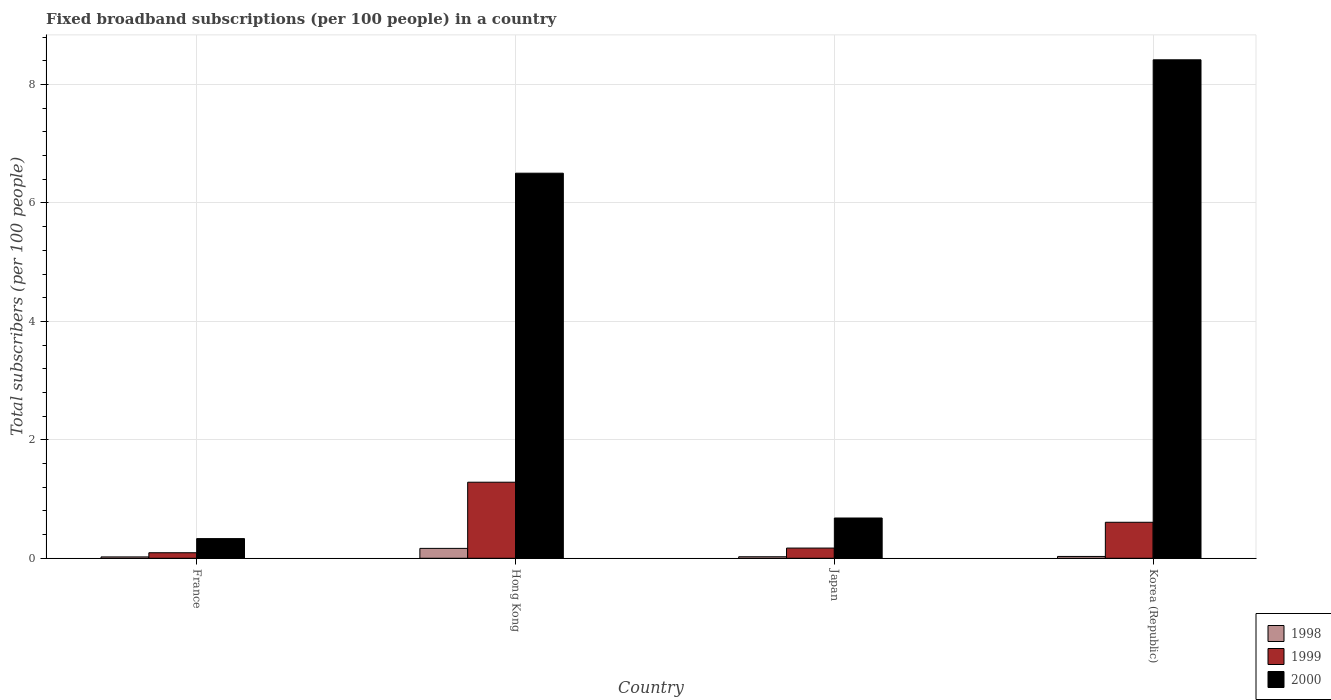How many different coloured bars are there?
Your answer should be very brief. 3. Are the number of bars per tick equal to the number of legend labels?
Give a very brief answer. Yes. How many bars are there on the 2nd tick from the left?
Your response must be concise. 3. What is the label of the 2nd group of bars from the left?
Your response must be concise. Hong Kong. In how many cases, is the number of bars for a given country not equal to the number of legend labels?
Your response must be concise. 0. What is the number of broadband subscriptions in 2000 in France?
Your answer should be compact. 0.33. Across all countries, what is the maximum number of broadband subscriptions in 2000?
Make the answer very short. 8.42. Across all countries, what is the minimum number of broadband subscriptions in 1999?
Keep it short and to the point. 0.09. In which country was the number of broadband subscriptions in 1999 maximum?
Your answer should be compact. Hong Kong. What is the total number of broadband subscriptions in 2000 in the graph?
Offer a very short reply. 15.93. What is the difference between the number of broadband subscriptions in 1998 in France and that in Japan?
Provide a short and direct response. -0. What is the difference between the number of broadband subscriptions in 1998 in Japan and the number of broadband subscriptions in 2000 in Korea (Republic)?
Ensure brevity in your answer.  -8.39. What is the average number of broadband subscriptions in 2000 per country?
Your answer should be compact. 3.98. What is the difference between the number of broadband subscriptions of/in 1998 and number of broadband subscriptions of/in 1999 in Korea (Republic)?
Ensure brevity in your answer.  -0.58. What is the ratio of the number of broadband subscriptions in 1999 in Hong Kong to that in Japan?
Offer a very short reply. 7.46. Is the number of broadband subscriptions in 1999 in Hong Kong less than that in Japan?
Make the answer very short. No. What is the difference between the highest and the second highest number of broadband subscriptions in 2000?
Your answer should be compact. 7.74. What is the difference between the highest and the lowest number of broadband subscriptions in 1999?
Give a very brief answer. 1.19. In how many countries, is the number of broadband subscriptions in 1999 greater than the average number of broadband subscriptions in 1999 taken over all countries?
Offer a very short reply. 2. Is the sum of the number of broadband subscriptions in 1999 in Hong Kong and Korea (Republic) greater than the maximum number of broadband subscriptions in 2000 across all countries?
Keep it short and to the point. No. What does the 2nd bar from the left in France represents?
Offer a terse response. 1999. What does the 3rd bar from the right in Japan represents?
Offer a terse response. 1998. How many bars are there?
Provide a succinct answer. 12. How many countries are there in the graph?
Ensure brevity in your answer.  4. What is the difference between two consecutive major ticks on the Y-axis?
Give a very brief answer. 2. How many legend labels are there?
Offer a terse response. 3. How are the legend labels stacked?
Ensure brevity in your answer.  Vertical. What is the title of the graph?
Offer a very short reply. Fixed broadband subscriptions (per 100 people) in a country. What is the label or title of the X-axis?
Your response must be concise. Country. What is the label or title of the Y-axis?
Keep it short and to the point. Total subscribers (per 100 people). What is the Total subscribers (per 100 people) of 1998 in France?
Give a very brief answer. 0.02. What is the Total subscribers (per 100 people) in 1999 in France?
Offer a terse response. 0.09. What is the Total subscribers (per 100 people) of 2000 in France?
Your answer should be very brief. 0.33. What is the Total subscribers (per 100 people) in 1998 in Hong Kong?
Provide a succinct answer. 0.17. What is the Total subscribers (per 100 people) in 1999 in Hong Kong?
Provide a succinct answer. 1.28. What is the Total subscribers (per 100 people) in 2000 in Hong Kong?
Offer a terse response. 6.5. What is the Total subscribers (per 100 people) in 1998 in Japan?
Provide a short and direct response. 0.03. What is the Total subscribers (per 100 people) in 1999 in Japan?
Your answer should be very brief. 0.17. What is the Total subscribers (per 100 people) in 2000 in Japan?
Offer a very short reply. 0.68. What is the Total subscribers (per 100 people) in 1998 in Korea (Republic)?
Offer a terse response. 0.03. What is the Total subscribers (per 100 people) of 1999 in Korea (Republic)?
Keep it short and to the point. 0.61. What is the Total subscribers (per 100 people) in 2000 in Korea (Republic)?
Your response must be concise. 8.42. Across all countries, what is the maximum Total subscribers (per 100 people) of 1998?
Keep it short and to the point. 0.17. Across all countries, what is the maximum Total subscribers (per 100 people) of 1999?
Make the answer very short. 1.28. Across all countries, what is the maximum Total subscribers (per 100 people) in 2000?
Keep it short and to the point. 8.42. Across all countries, what is the minimum Total subscribers (per 100 people) of 1998?
Provide a succinct answer. 0.02. Across all countries, what is the minimum Total subscribers (per 100 people) in 1999?
Your response must be concise. 0.09. Across all countries, what is the minimum Total subscribers (per 100 people) in 2000?
Your answer should be very brief. 0.33. What is the total Total subscribers (per 100 people) of 1998 in the graph?
Provide a succinct answer. 0.25. What is the total Total subscribers (per 100 people) of 1999 in the graph?
Your answer should be compact. 2.16. What is the total Total subscribers (per 100 people) in 2000 in the graph?
Keep it short and to the point. 15.93. What is the difference between the Total subscribers (per 100 people) of 1998 in France and that in Hong Kong?
Ensure brevity in your answer.  -0.14. What is the difference between the Total subscribers (per 100 people) of 1999 in France and that in Hong Kong?
Offer a very short reply. -1.19. What is the difference between the Total subscribers (per 100 people) of 2000 in France and that in Hong Kong?
Offer a terse response. -6.17. What is the difference between the Total subscribers (per 100 people) of 1998 in France and that in Japan?
Provide a short and direct response. -0. What is the difference between the Total subscribers (per 100 people) in 1999 in France and that in Japan?
Offer a terse response. -0.08. What is the difference between the Total subscribers (per 100 people) of 2000 in France and that in Japan?
Your answer should be very brief. -0.35. What is the difference between the Total subscribers (per 100 people) of 1998 in France and that in Korea (Republic)?
Your answer should be very brief. -0.01. What is the difference between the Total subscribers (per 100 people) in 1999 in France and that in Korea (Republic)?
Give a very brief answer. -0.51. What is the difference between the Total subscribers (per 100 people) in 2000 in France and that in Korea (Republic)?
Make the answer very short. -8.09. What is the difference between the Total subscribers (per 100 people) of 1998 in Hong Kong and that in Japan?
Ensure brevity in your answer.  0.14. What is the difference between the Total subscribers (per 100 people) of 1999 in Hong Kong and that in Japan?
Provide a succinct answer. 1.11. What is the difference between the Total subscribers (per 100 people) in 2000 in Hong Kong and that in Japan?
Offer a terse response. 5.82. What is the difference between the Total subscribers (per 100 people) of 1998 in Hong Kong and that in Korea (Republic)?
Provide a short and direct response. 0.14. What is the difference between the Total subscribers (per 100 people) in 1999 in Hong Kong and that in Korea (Republic)?
Make the answer very short. 0.68. What is the difference between the Total subscribers (per 100 people) of 2000 in Hong Kong and that in Korea (Republic)?
Your response must be concise. -1.91. What is the difference between the Total subscribers (per 100 people) in 1998 in Japan and that in Korea (Republic)?
Keep it short and to the point. -0.01. What is the difference between the Total subscribers (per 100 people) in 1999 in Japan and that in Korea (Republic)?
Give a very brief answer. -0.44. What is the difference between the Total subscribers (per 100 people) in 2000 in Japan and that in Korea (Republic)?
Provide a succinct answer. -7.74. What is the difference between the Total subscribers (per 100 people) of 1998 in France and the Total subscribers (per 100 people) of 1999 in Hong Kong?
Your answer should be compact. -1.26. What is the difference between the Total subscribers (per 100 people) in 1998 in France and the Total subscribers (per 100 people) in 2000 in Hong Kong?
Give a very brief answer. -6.48. What is the difference between the Total subscribers (per 100 people) in 1999 in France and the Total subscribers (per 100 people) in 2000 in Hong Kong?
Your answer should be compact. -6.41. What is the difference between the Total subscribers (per 100 people) in 1998 in France and the Total subscribers (per 100 people) in 1999 in Japan?
Make the answer very short. -0.15. What is the difference between the Total subscribers (per 100 people) of 1998 in France and the Total subscribers (per 100 people) of 2000 in Japan?
Provide a succinct answer. -0.66. What is the difference between the Total subscribers (per 100 people) of 1999 in France and the Total subscribers (per 100 people) of 2000 in Japan?
Your response must be concise. -0.59. What is the difference between the Total subscribers (per 100 people) in 1998 in France and the Total subscribers (per 100 people) in 1999 in Korea (Republic)?
Give a very brief answer. -0.58. What is the difference between the Total subscribers (per 100 people) of 1998 in France and the Total subscribers (per 100 people) of 2000 in Korea (Republic)?
Your response must be concise. -8.39. What is the difference between the Total subscribers (per 100 people) of 1999 in France and the Total subscribers (per 100 people) of 2000 in Korea (Republic)?
Provide a succinct answer. -8.32. What is the difference between the Total subscribers (per 100 people) in 1998 in Hong Kong and the Total subscribers (per 100 people) in 1999 in Japan?
Give a very brief answer. -0.01. What is the difference between the Total subscribers (per 100 people) in 1998 in Hong Kong and the Total subscribers (per 100 people) in 2000 in Japan?
Your answer should be very brief. -0.51. What is the difference between the Total subscribers (per 100 people) in 1999 in Hong Kong and the Total subscribers (per 100 people) in 2000 in Japan?
Provide a short and direct response. 0.6. What is the difference between the Total subscribers (per 100 people) of 1998 in Hong Kong and the Total subscribers (per 100 people) of 1999 in Korea (Republic)?
Your response must be concise. -0.44. What is the difference between the Total subscribers (per 100 people) in 1998 in Hong Kong and the Total subscribers (per 100 people) in 2000 in Korea (Republic)?
Your response must be concise. -8.25. What is the difference between the Total subscribers (per 100 people) of 1999 in Hong Kong and the Total subscribers (per 100 people) of 2000 in Korea (Republic)?
Ensure brevity in your answer.  -7.13. What is the difference between the Total subscribers (per 100 people) in 1998 in Japan and the Total subscribers (per 100 people) in 1999 in Korea (Republic)?
Your answer should be very brief. -0.58. What is the difference between the Total subscribers (per 100 people) in 1998 in Japan and the Total subscribers (per 100 people) in 2000 in Korea (Republic)?
Keep it short and to the point. -8.39. What is the difference between the Total subscribers (per 100 people) of 1999 in Japan and the Total subscribers (per 100 people) of 2000 in Korea (Republic)?
Your answer should be very brief. -8.25. What is the average Total subscribers (per 100 people) of 1998 per country?
Your answer should be compact. 0.06. What is the average Total subscribers (per 100 people) of 1999 per country?
Provide a short and direct response. 0.54. What is the average Total subscribers (per 100 people) in 2000 per country?
Give a very brief answer. 3.98. What is the difference between the Total subscribers (per 100 people) of 1998 and Total subscribers (per 100 people) of 1999 in France?
Ensure brevity in your answer.  -0.07. What is the difference between the Total subscribers (per 100 people) of 1998 and Total subscribers (per 100 people) of 2000 in France?
Offer a terse response. -0.31. What is the difference between the Total subscribers (per 100 people) in 1999 and Total subscribers (per 100 people) in 2000 in France?
Provide a short and direct response. -0.24. What is the difference between the Total subscribers (per 100 people) of 1998 and Total subscribers (per 100 people) of 1999 in Hong Kong?
Make the answer very short. -1.12. What is the difference between the Total subscribers (per 100 people) in 1998 and Total subscribers (per 100 people) in 2000 in Hong Kong?
Make the answer very short. -6.34. What is the difference between the Total subscribers (per 100 people) of 1999 and Total subscribers (per 100 people) of 2000 in Hong Kong?
Give a very brief answer. -5.22. What is the difference between the Total subscribers (per 100 people) in 1998 and Total subscribers (per 100 people) in 1999 in Japan?
Give a very brief answer. -0.15. What is the difference between the Total subscribers (per 100 people) in 1998 and Total subscribers (per 100 people) in 2000 in Japan?
Make the answer very short. -0.65. What is the difference between the Total subscribers (per 100 people) in 1999 and Total subscribers (per 100 people) in 2000 in Japan?
Ensure brevity in your answer.  -0.51. What is the difference between the Total subscribers (per 100 people) of 1998 and Total subscribers (per 100 people) of 1999 in Korea (Republic)?
Offer a terse response. -0.58. What is the difference between the Total subscribers (per 100 people) of 1998 and Total subscribers (per 100 people) of 2000 in Korea (Republic)?
Offer a terse response. -8.39. What is the difference between the Total subscribers (per 100 people) of 1999 and Total subscribers (per 100 people) of 2000 in Korea (Republic)?
Keep it short and to the point. -7.81. What is the ratio of the Total subscribers (per 100 people) in 1998 in France to that in Hong Kong?
Offer a very short reply. 0.14. What is the ratio of the Total subscribers (per 100 people) of 1999 in France to that in Hong Kong?
Your answer should be very brief. 0.07. What is the ratio of the Total subscribers (per 100 people) in 2000 in France to that in Hong Kong?
Your response must be concise. 0.05. What is the ratio of the Total subscribers (per 100 people) of 1998 in France to that in Japan?
Give a very brief answer. 0.9. What is the ratio of the Total subscribers (per 100 people) in 1999 in France to that in Japan?
Make the answer very short. 0.54. What is the ratio of the Total subscribers (per 100 people) of 2000 in France to that in Japan?
Make the answer very short. 0.49. What is the ratio of the Total subscribers (per 100 people) of 1998 in France to that in Korea (Republic)?
Ensure brevity in your answer.  0.75. What is the ratio of the Total subscribers (per 100 people) of 1999 in France to that in Korea (Republic)?
Ensure brevity in your answer.  0.15. What is the ratio of the Total subscribers (per 100 people) in 2000 in France to that in Korea (Republic)?
Provide a succinct answer. 0.04. What is the ratio of the Total subscribers (per 100 people) in 1998 in Hong Kong to that in Japan?
Provide a succinct answer. 6.53. What is the ratio of the Total subscribers (per 100 people) of 1999 in Hong Kong to that in Japan?
Your response must be concise. 7.46. What is the ratio of the Total subscribers (per 100 people) in 2000 in Hong Kong to that in Japan?
Ensure brevity in your answer.  9.56. What is the ratio of the Total subscribers (per 100 people) of 1998 in Hong Kong to that in Korea (Republic)?
Ensure brevity in your answer.  5.42. What is the ratio of the Total subscribers (per 100 people) of 1999 in Hong Kong to that in Korea (Republic)?
Provide a short and direct response. 2.11. What is the ratio of the Total subscribers (per 100 people) of 2000 in Hong Kong to that in Korea (Republic)?
Ensure brevity in your answer.  0.77. What is the ratio of the Total subscribers (per 100 people) in 1998 in Japan to that in Korea (Republic)?
Ensure brevity in your answer.  0.83. What is the ratio of the Total subscribers (per 100 people) of 1999 in Japan to that in Korea (Republic)?
Your answer should be very brief. 0.28. What is the ratio of the Total subscribers (per 100 people) in 2000 in Japan to that in Korea (Republic)?
Your answer should be very brief. 0.08. What is the difference between the highest and the second highest Total subscribers (per 100 people) of 1998?
Offer a terse response. 0.14. What is the difference between the highest and the second highest Total subscribers (per 100 people) of 1999?
Provide a succinct answer. 0.68. What is the difference between the highest and the second highest Total subscribers (per 100 people) in 2000?
Offer a terse response. 1.91. What is the difference between the highest and the lowest Total subscribers (per 100 people) in 1998?
Ensure brevity in your answer.  0.14. What is the difference between the highest and the lowest Total subscribers (per 100 people) of 1999?
Your answer should be compact. 1.19. What is the difference between the highest and the lowest Total subscribers (per 100 people) in 2000?
Offer a terse response. 8.09. 